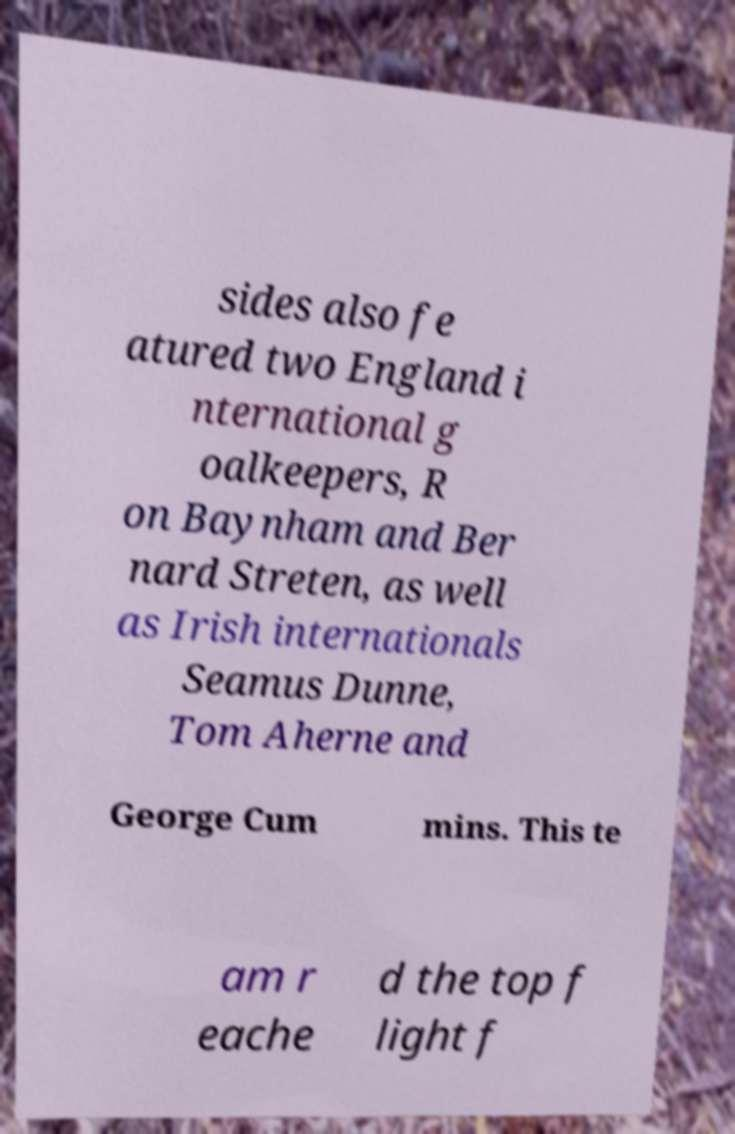There's text embedded in this image that I need extracted. Can you transcribe it verbatim? sides also fe atured two England i nternational g oalkeepers, R on Baynham and Ber nard Streten, as well as Irish internationals Seamus Dunne, Tom Aherne and George Cum mins. This te am r eache d the top f light f 